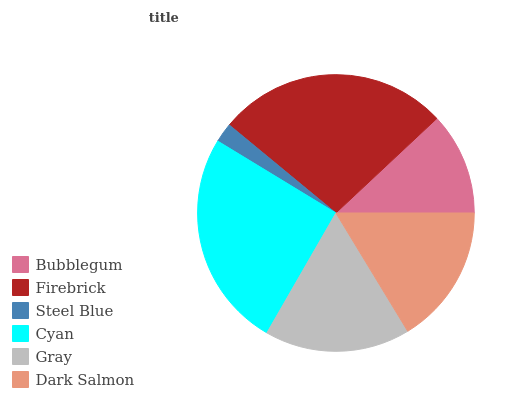Is Steel Blue the minimum?
Answer yes or no. Yes. Is Firebrick the maximum?
Answer yes or no. Yes. Is Firebrick the minimum?
Answer yes or no. No. Is Steel Blue the maximum?
Answer yes or no. No. Is Firebrick greater than Steel Blue?
Answer yes or no. Yes. Is Steel Blue less than Firebrick?
Answer yes or no. Yes. Is Steel Blue greater than Firebrick?
Answer yes or no. No. Is Firebrick less than Steel Blue?
Answer yes or no. No. Is Gray the high median?
Answer yes or no. Yes. Is Dark Salmon the low median?
Answer yes or no. Yes. Is Dark Salmon the high median?
Answer yes or no. No. Is Gray the low median?
Answer yes or no. No. 